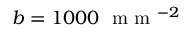<formula> <loc_0><loc_0><loc_500><loc_500>b = 1 0 0 0 m m ^ { - 2 }</formula> 